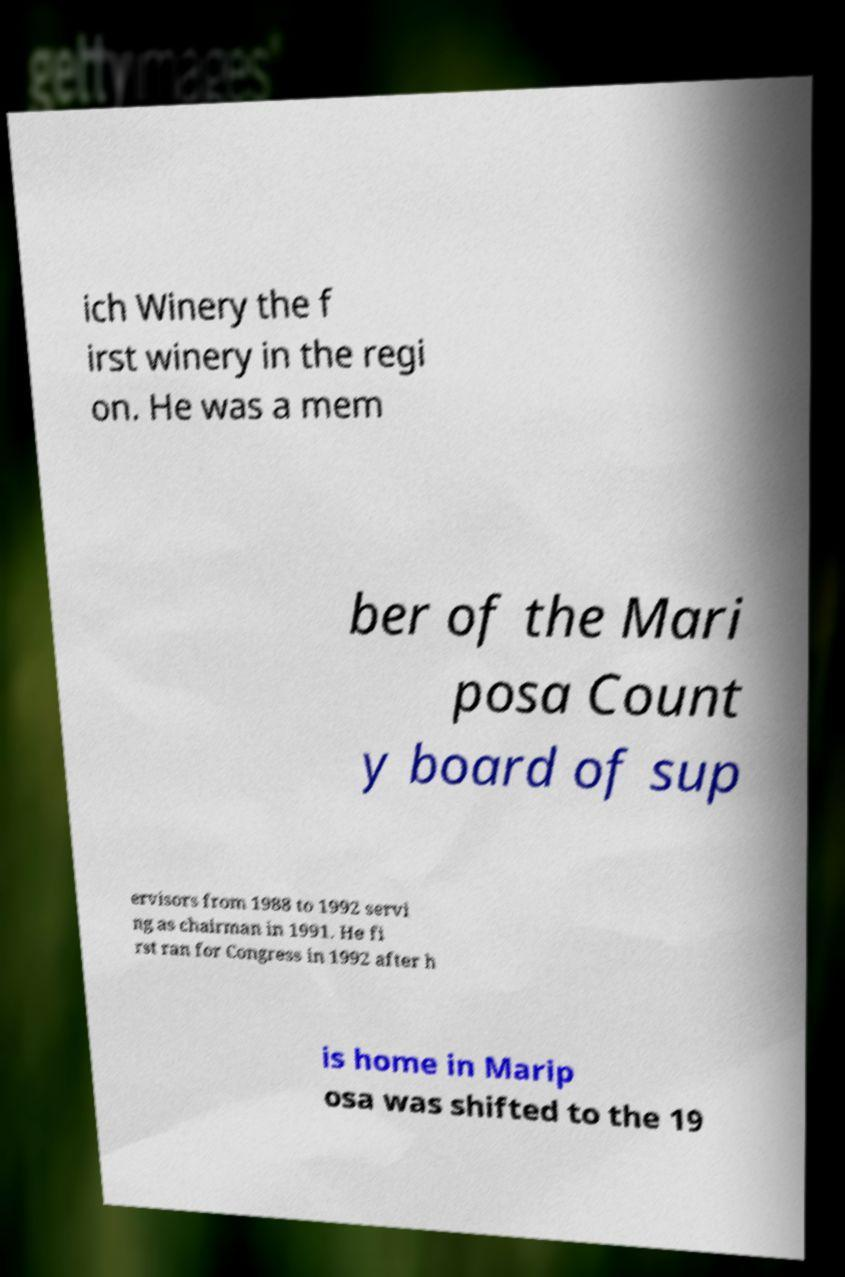I need the written content from this picture converted into text. Can you do that? ich Winery the f irst winery in the regi on. He was a mem ber of the Mari posa Count y board of sup ervisors from 1988 to 1992 servi ng as chairman in 1991. He fi rst ran for Congress in 1992 after h is home in Marip osa was shifted to the 19 